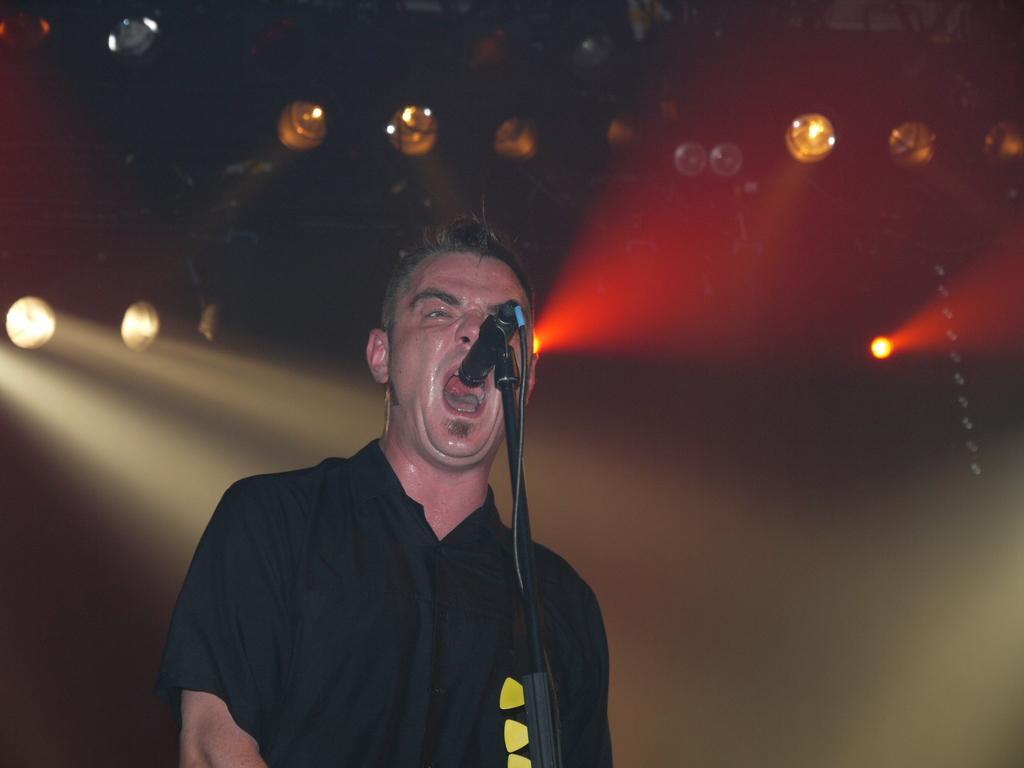Describe this image in one or two sentences. In this image I can see a person wearing black and yellow colored dress is standing in front of a microphone. In the background I can see few lights and the dark background. 